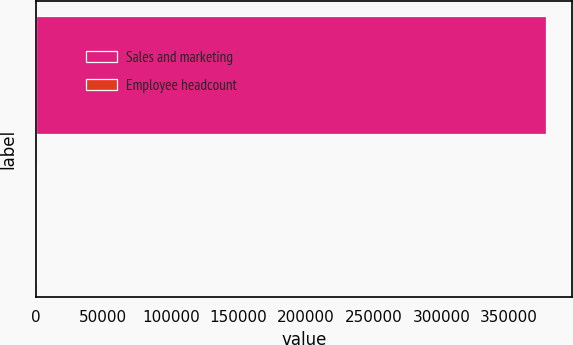Convert chart to OTSL. <chart><loc_0><loc_0><loc_500><loc_500><bar_chart><fcel>Sales and marketing<fcel>Employee headcount<nl><fcel>377550<fcel>989<nl></chart> 